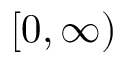Convert formula to latex. <formula><loc_0><loc_0><loc_500><loc_500>[ 0 , \infty )</formula> 